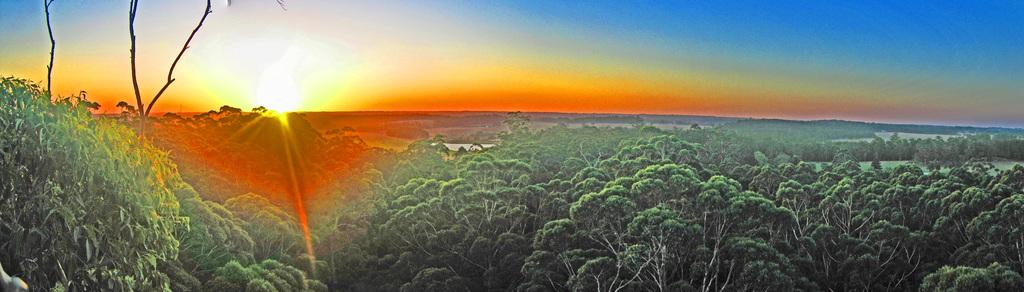What type of vegetation can be seen in the image? There are trees in the image. What natural element is visible in the image? There is water visible in the image. What can be seen in the background of the image? The sky is visible in the background of the image. Can the sun be seen in the image? Yes, the sun is observable in the sky. What type of soap is floating in the water in the image? There is no soap present in the image; it features trees, water, and the sky. Can you describe the face of the person in the image? There is no person present in the image, so it is not possible to describe a face. 